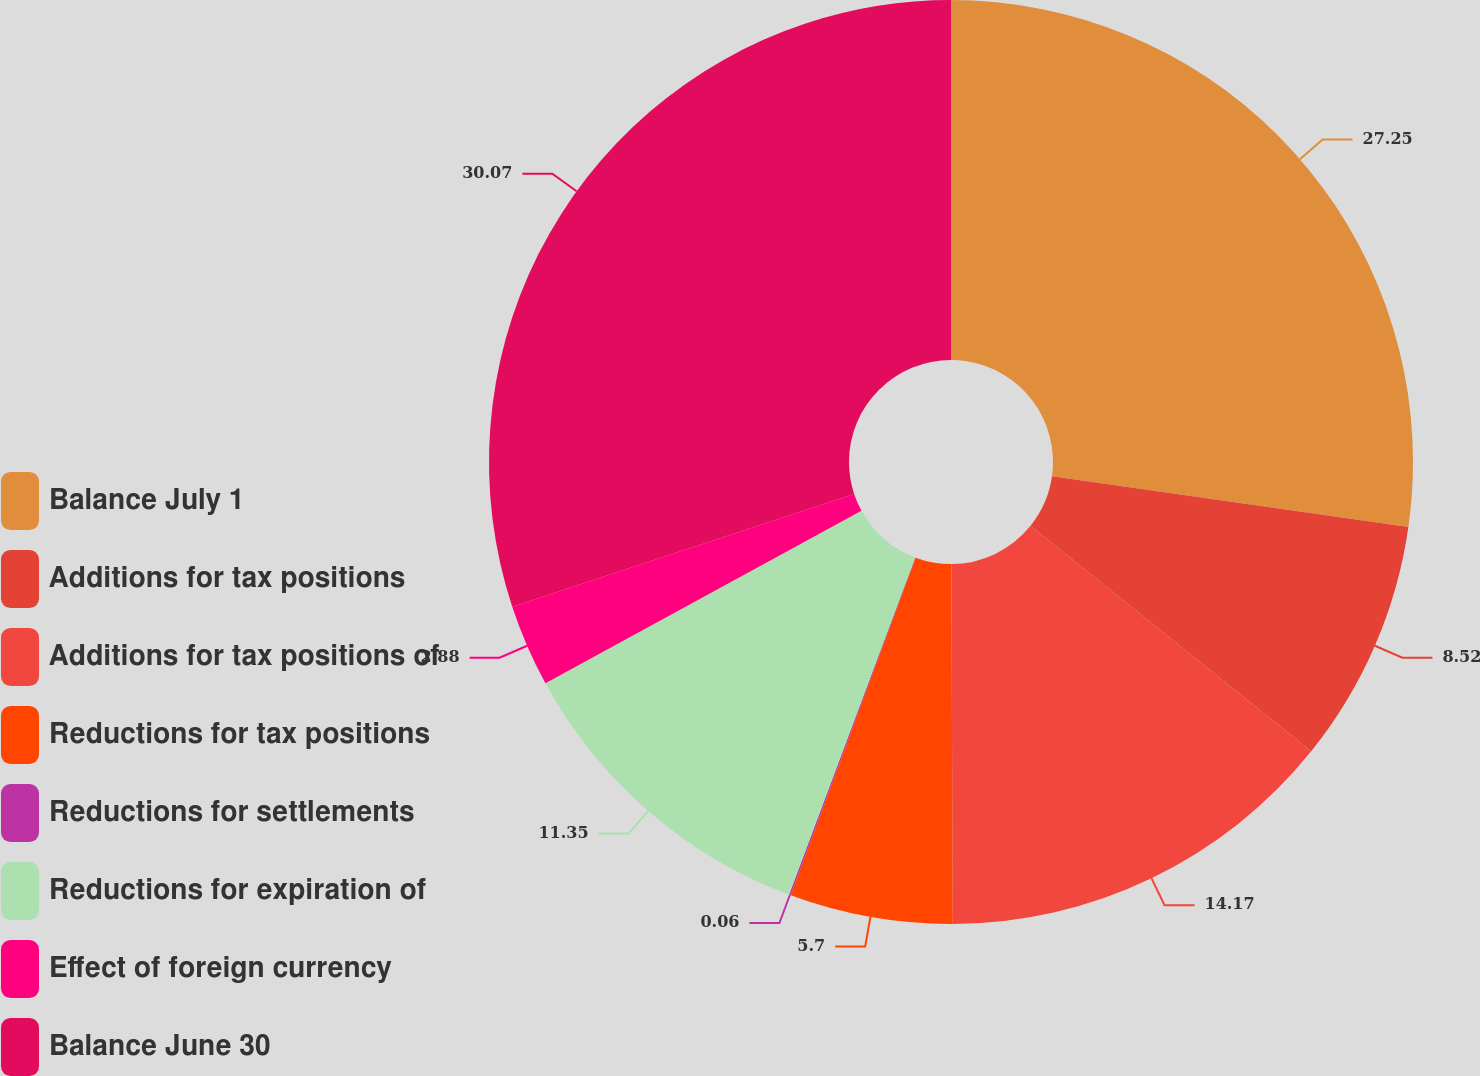<chart> <loc_0><loc_0><loc_500><loc_500><pie_chart><fcel>Balance July 1<fcel>Additions for tax positions<fcel>Additions for tax positions of<fcel>Reductions for tax positions<fcel>Reductions for settlements<fcel>Reductions for expiration of<fcel>Effect of foreign currency<fcel>Balance June 30<nl><fcel>27.25%<fcel>8.52%<fcel>14.17%<fcel>5.7%<fcel>0.06%<fcel>11.35%<fcel>2.88%<fcel>30.07%<nl></chart> 